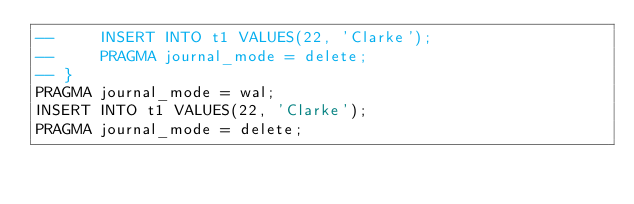Convert code to text. <code><loc_0><loc_0><loc_500><loc_500><_SQL_>--     INSERT INTO t1 VALUES(22, 'Clarke');
--     PRAGMA journal_mode = delete;
-- }
PRAGMA journal_mode = wal;
INSERT INTO t1 VALUES(22, 'Clarke');
PRAGMA journal_mode = delete;</code> 